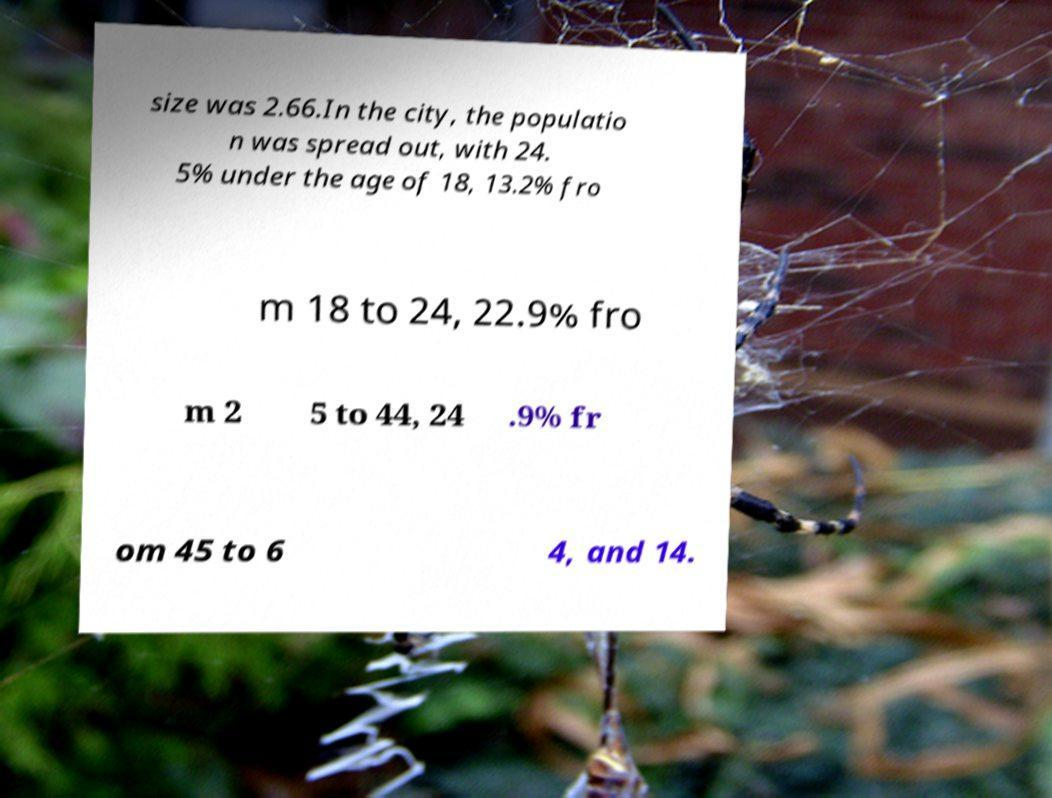What messages or text are displayed in this image? I need them in a readable, typed format. size was 2.66.In the city, the populatio n was spread out, with 24. 5% under the age of 18, 13.2% fro m 18 to 24, 22.9% fro m 2 5 to 44, 24 .9% fr om 45 to 6 4, and 14. 